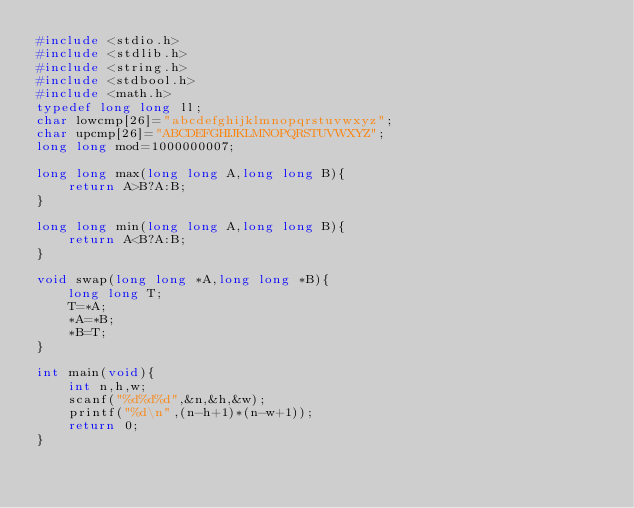<code> <loc_0><loc_0><loc_500><loc_500><_C_>#include <stdio.h>
#include <stdlib.h>
#include <string.h>
#include <stdbool.h>
#include <math.h>
typedef long long ll;
char lowcmp[26]="abcdefghijklmnopqrstuvwxyz";
char upcmp[26]="ABCDEFGHIJKLMNOPQRSTUVWXYZ";
long long mod=1000000007;

long long max(long long A,long long B){
    return A>B?A:B;
}

long long min(long long A,long long B){
    return A<B?A:B;
}

void swap(long long *A,long long *B){
    long long T;
    T=*A;
    *A=*B;
    *B=T;
}

int main(void){
    int n,h,w;
    scanf("%d%d%d",&n,&h,&w);
    printf("%d\n",(n-h+1)*(n-w+1));
    return 0;
}
</code> 